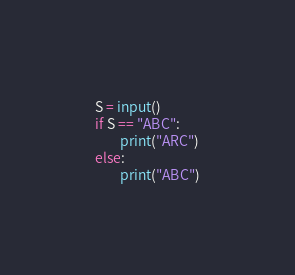Convert code to text. <code><loc_0><loc_0><loc_500><loc_500><_Python_>S = input()
if S == "ABC":
        print("ARC")
else:
        print("ABC")</code> 